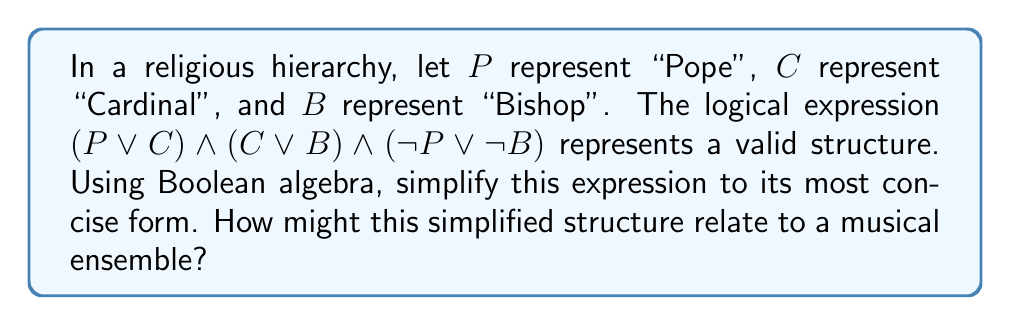Can you solve this math problem? Let's simplify the expression step by step using Boolean algebra laws:

1) Start with the given expression:
   $$(P \lor C) \land (C \lor B) \land (\neg P \lor \neg B)$$

2) Apply the distributive law to the first two terms:
   $$(P \land (C \lor B)) \lor (C \land (C \lor B)) \land (\neg P \lor \neg B)$$

3) Simplify $(C \land (C \lor B))$ to $C$ using the absorption law:
   $$(P \land (C \lor B)) \lor C \land (\neg P \lor \neg B)$$

4) Distribute $C$ over $(\neg P \lor \neg B)$:
   $$(P \land (C \lor B)) \lor (C \land \neg P) \lor (C \land \neg B)$$

5) In the first term, distribute $P$ over $(C \lor B)$:
   $$(P \land C) \lor (P \land B) \lor (C \land \neg P) \lor (C \land \neg B)$$

6) The terms $(P \land B)$ and $(C \land \neg B)$ are contradictory to $(\neg P \lor \neg B)$ in the original expression, so they can be eliminated:
   $$(P \land C) \lor (C \land \neg P)$$

7) This can be further simplified to just $C$ using the absorption law:
   $$C$$

This simplified expression suggests that in this hierarchy, the Cardinal (C) is the key position, connecting the Pope and the Bishop.

Relating to a musical ensemble, this structure could be likened to a conductor (Cardinal) who acts as an intermediary between the composer (Pope) and the musicians (Bishops). The conductor interprets the composer's vision and directs the musicians, playing a central role in the hierarchy of the musical performance.
Answer: $$C$$ 